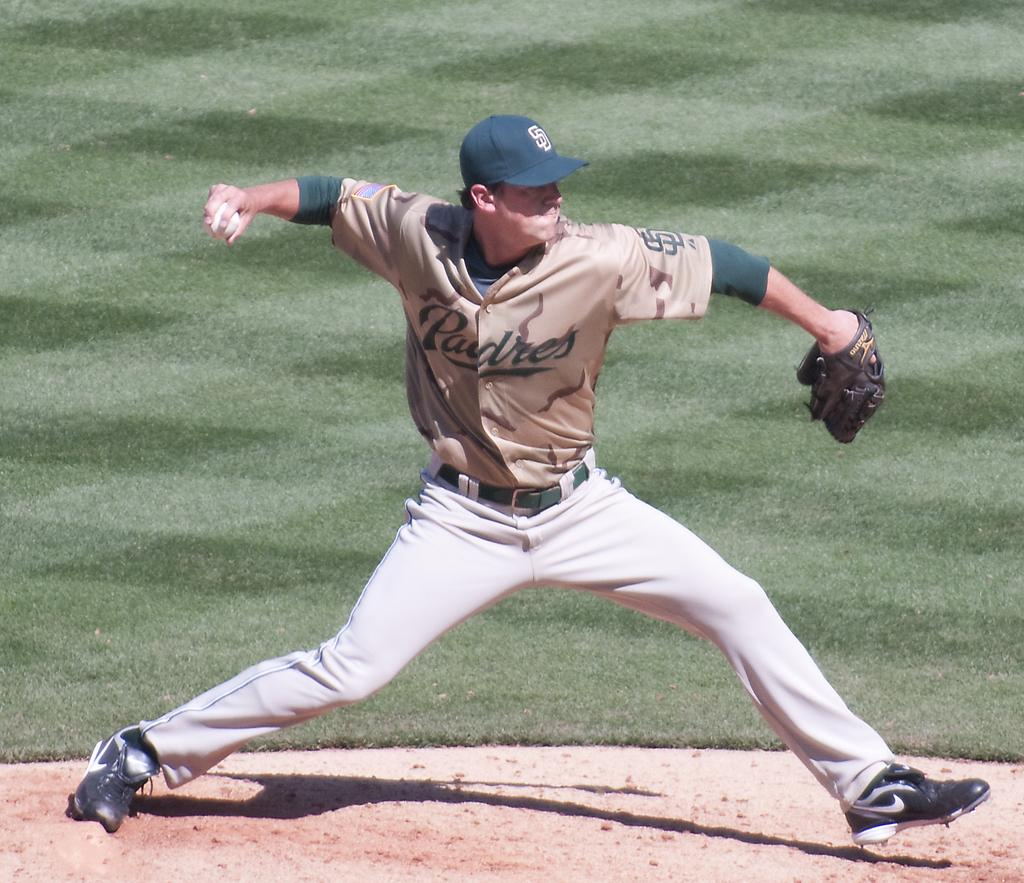<image>
Provide a brief description of the given image. The pitcher for the Padres baseball team is throwing the ball. 